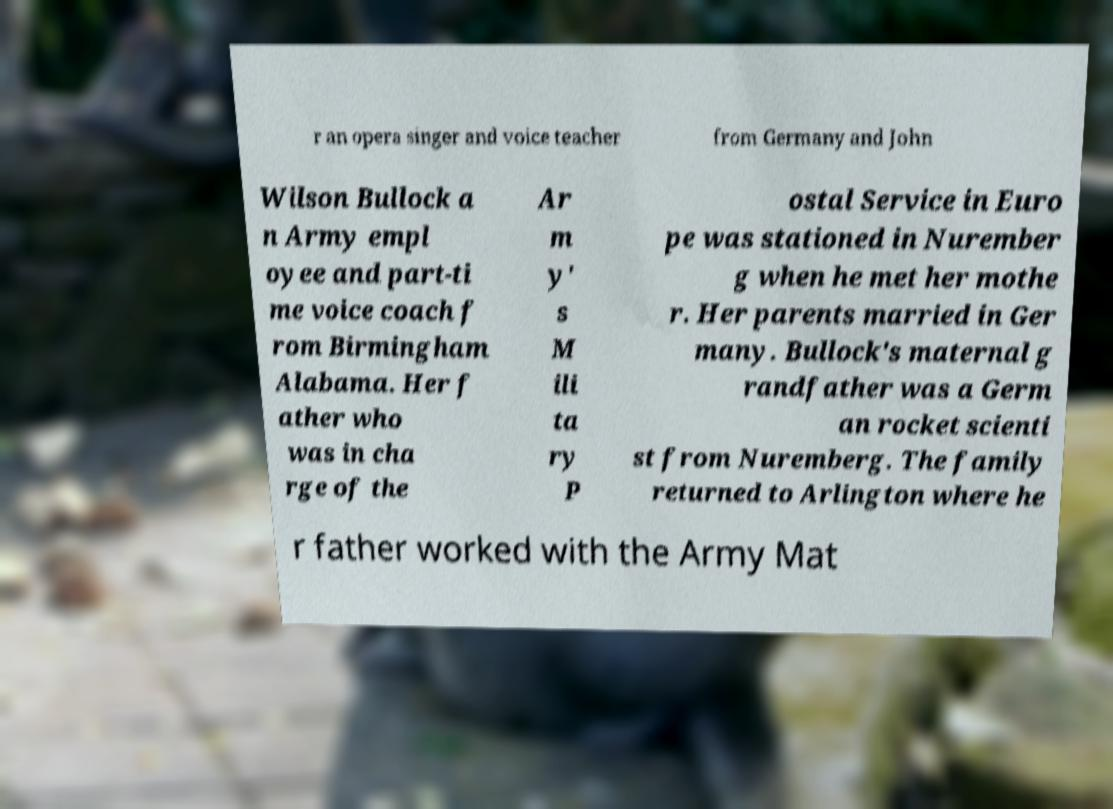For documentation purposes, I need the text within this image transcribed. Could you provide that? r an opera singer and voice teacher from Germany and John Wilson Bullock a n Army empl oyee and part-ti me voice coach f rom Birmingham Alabama. Her f ather who was in cha rge of the Ar m y' s M ili ta ry P ostal Service in Euro pe was stationed in Nurember g when he met her mothe r. Her parents married in Ger many. Bullock's maternal g randfather was a Germ an rocket scienti st from Nuremberg. The family returned to Arlington where he r father worked with the Army Mat 